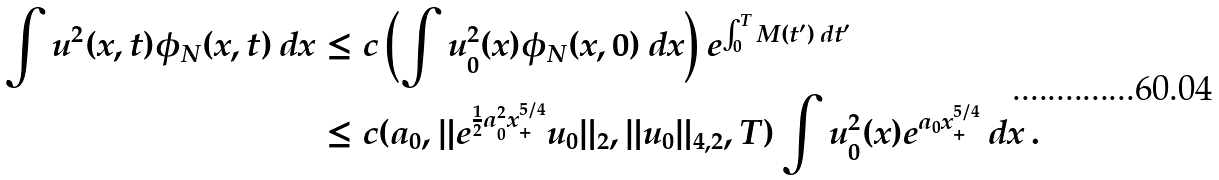<formula> <loc_0><loc_0><loc_500><loc_500>\int u ^ { 2 } ( x , t ) \phi _ { N } ( x , t ) \, d x & \leq c \left ( \int u _ { 0 } ^ { 2 } ( x ) \phi _ { N } ( x , 0 ) \, d x \right ) e ^ { \int _ { 0 } ^ { T } M ( t ^ { \prime } ) \, d t ^ { \prime } } \\ & \leq c ( a _ { 0 } , \| e ^ { \frac { 1 } { 2 } a _ { 0 } ^ { 2 } x _ { + } ^ { 5 / 4 } } u _ { 0 } \| _ { 2 } , \| u _ { 0 } \| _ { 4 , 2 } , T ) \int u _ { 0 } ^ { 2 } ( x ) e ^ { a _ { 0 } x _ { + } ^ { 5 / 4 } } \, d x \, .</formula> 